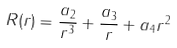<formula> <loc_0><loc_0><loc_500><loc_500>R ( r ) = \frac { a _ { 2 } } { r ^ { 3 } } + \frac { a _ { 3 } } { r } + a _ { 4 } r ^ { 2 }</formula> 